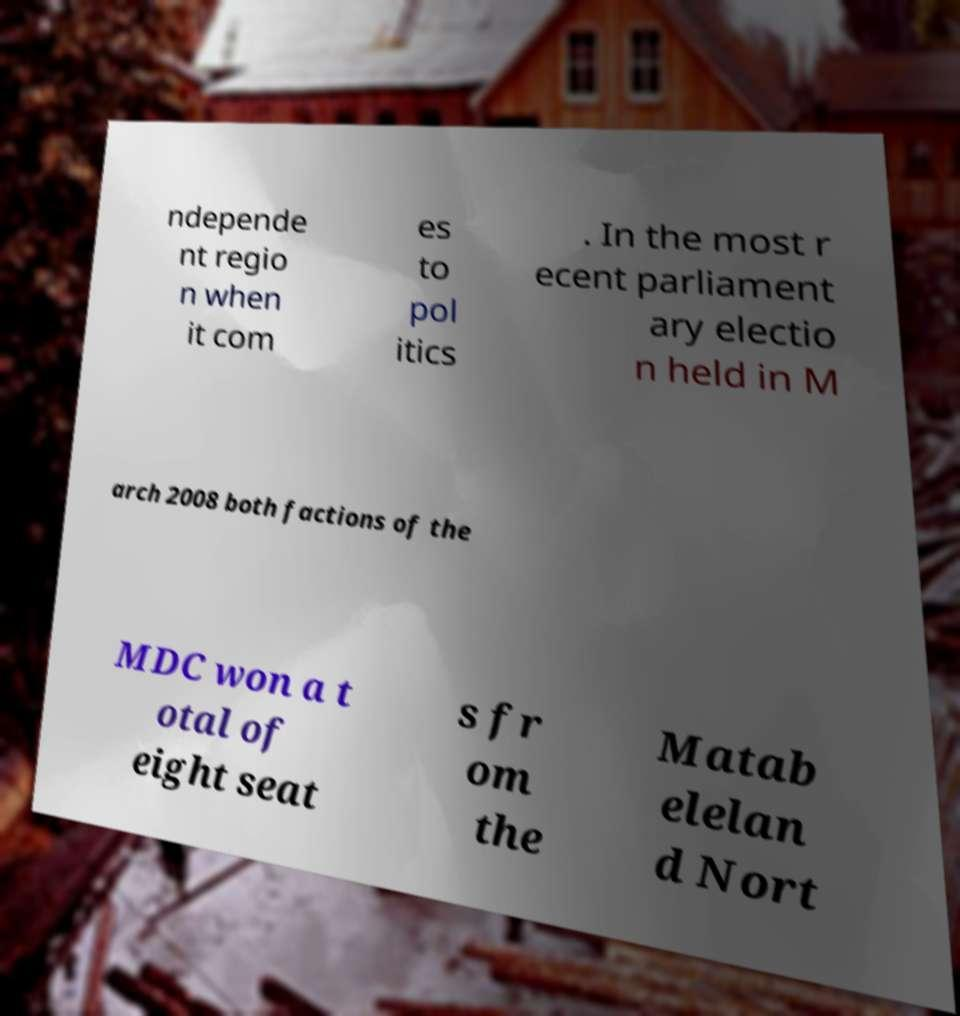There's text embedded in this image that I need extracted. Can you transcribe it verbatim? ndepende nt regio n when it com es to pol itics . In the most r ecent parliament ary electio n held in M arch 2008 both factions of the MDC won a t otal of eight seat s fr om the Matab elelan d Nort 